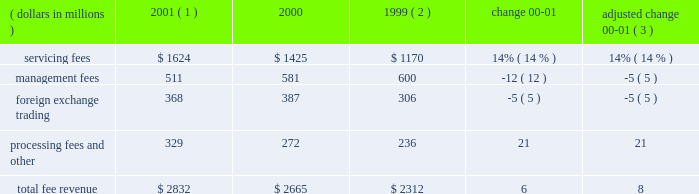An average of 7.1 in 2000 .
The top 100 largest clients used an average of 11.3 products in 2001 , up from an average of 11.2 in 2000 .
State street benefits significantly from its ability to derive revenue from the transaction flows of clients .
This occurs through the management of cash positions , including deposit balances and other short-term investment activities , using state street 2019s balance sheet capacity .
Significant foreign currency transaction volumes provide potential for foreign exchange trading revenue as well .
Fee revenue total operating fee revenuewas $ 2.8 billion in 2001 , compared to $ 2.7 billion in 2000 , an increase of 6% ( 6 % ) .
Adjusted for the formation of citistreet , the growth in fee revenue was 8% ( 8 % ) .
Growth in servicing fees of $ 199million , or 14% ( 14 % ) , was the primary contributor to the increase in fee revenue .
This growth primarily reflects several large client wins installed starting in the latter half of 2000 and continuing throughout 2001 , and strength in fee revenue from securities lending .
Declines in equity market values worldwide offset some of the growth in servicing fees .
Management fees were down 5% ( 5 % ) , adjusted for the formation of citistreet , reflecting the decline in theworldwide equitymarkets .
Foreign exchange trading revenue was down 5% ( 5 % ) , reflecting lower currency volatility , and processing fees and other revenue was up 21% ( 21 % ) , primarily due to gains on the sales of investment securities .
Servicing and management fees are a function of several factors , including the mix and volume of assets under custody and assets under management , securities positions held , and portfolio transactions , as well as types of products and services used by clients .
State street estimates , based on a study conducted in 2000 , that a 10% ( 10 % ) increase or decrease in worldwide equity values would cause a corresponding change in state street 2019s total revenue of approximately 2% ( 2 % ) .
If bond values were to increase or decrease by 10% ( 10 % ) , state street would anticipate a corresponding change of approximately 1% ( 1 % ) in its total revenue .
Securities lending revenue in 2001 increased approximately 40% ( 40 % ) over 2000 .
Securities lending revenue is reflected in both servicing fees and management fees .
Securities lending revenue is a function of the volume of securities lent and interest rate spreads .
While volumes increased in 2001 , the year-over-year increase is primarily due to wider interest rate spreads resulting from the unusual occurrence of eleven reductions in the u.s .
Federal funds target rate during 2001 .
F e e r e v e n u e ( dollars in millions ) 2001 ( 1 ) 2000 1999 ( 2 ) change adjusted change 00-01 ( 3 ) .
( 1 ) 2001 results exclude the write-off of state street 2019s total investment in bridge of $ 50 million ( 2 ) 1999 results exclude the one-time charge of $ 57 million related to the repositioning of the investment portfolio ( 3 ) 2000 results adjusted for the formation of citistreet 4 state street corporation .
What is the growth rate in total fee revenue in 2000? 
Computations: ((2665 - 2312) / 2312)
Answer: 0.15268. 